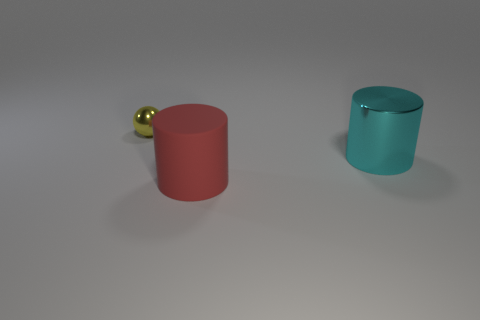There is another object that is the same shape as the cyan object; what is its size?
Keep it short and to the point. Large. Are there any other things that are the same material as the tiny ball?
Make the answer very short. Yes. The yellow metal object has what shape?
Your response must be concise. Sphere. Is there any other thing that is the same color as the tiny thing?
Ensure brevity in your answer.  No. What size is the sphere that is the same material as the cyan thing?
Provide a succinct answer. Small. There is a large cyan object; does it have the same shape as the thing that is behind the large cyan shiny cylinder?
Provide a succinct answer. No. The metal cylinder is what size?
Offer a very short reply. Large. Is the number of tiny yellow metallic spheres in front of the big metallic object less than the number of purple rubber balls?
Offer a terse response. No. What number of balls have the same size as the cyan metallic cylinder?
Make the answer very short. 0. Is the color of the large cylinder that is on the left side of the big cyan cylinder the same as the big thing right of the big matte thing?
Provide a short and direct response. No. 